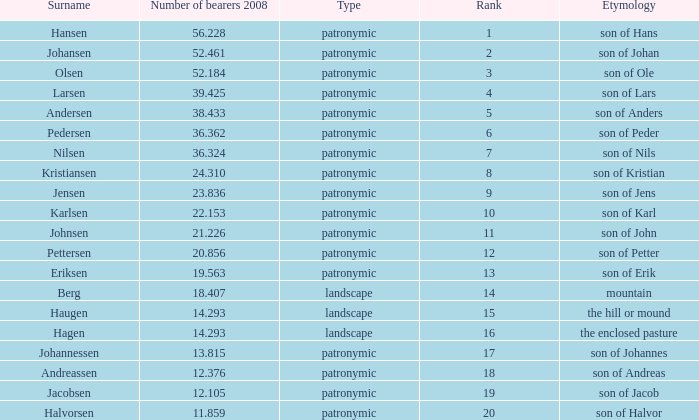Write the full table. {'header': ['Surname', 'Number of bearers 2008', 'Type', 'Rank', 'Etymology'], 'rows': [['Hansen', '56.228', 'patronymic', '1', 'son of Hans'], ['Johansen', '52.461', 'patronymic', '2', 'son of Johan'], ['Olsen', '52.184', 'patronymic', '3', 'son of Ole'], ['Larsen', '39.425', 'patronymic', '4', 'son of Lars'], ['Andersen', '38.433', 'patronymic', '5', 'son of Anders'], ['Pedersen', '36.362', 'patronymic', '6', 'son of Peder'], ['Nilsen', '36.324', 'patronymic', '7', 'son of Nils'], ['Kristiansen', '24.310', 'patronymic', '8', 'son of Kristian'], ['Jensen', '23.836', 'patronymic', '9', 'son of Jens'], ['Karlsen', '22.153', 'patronymic', '10', 'son of Karl'], ['Johnsen', '21.226', 'patronymic', '11', 'son of John'], ['Pettersen', '20.856', 'patronymic', '12', 'son of Petter'], ['Eriksen', '19.563', 'patronymic', '13', 'son of Erik'], ['Berg', '18.407', 'landscape', '14', 'mountain'], ['Haugen', '14.293', 'landscape', '15', 'the hill or mound'], ['Hagen', '14.293', 'landscape', '16', 'the enclosed pasture'], ['Johannessen', '13.815', 'patronymic', '17', 'son of Johannes'], ['Andreassen', '12.376', 'patronymic', '18', 'son of Andreas'], ['Jacobsen', '12.105', 'patronymic', '19', 'son of Jacob'], ['Halvorsen', '11.859', 'patronymic', '20', 'son of Halvor']]} What is Type, when Rank is greater than 6, when Number of Bearers 2008 is greater than 13.815, and when Surname is Eriksen? Patronymic. 